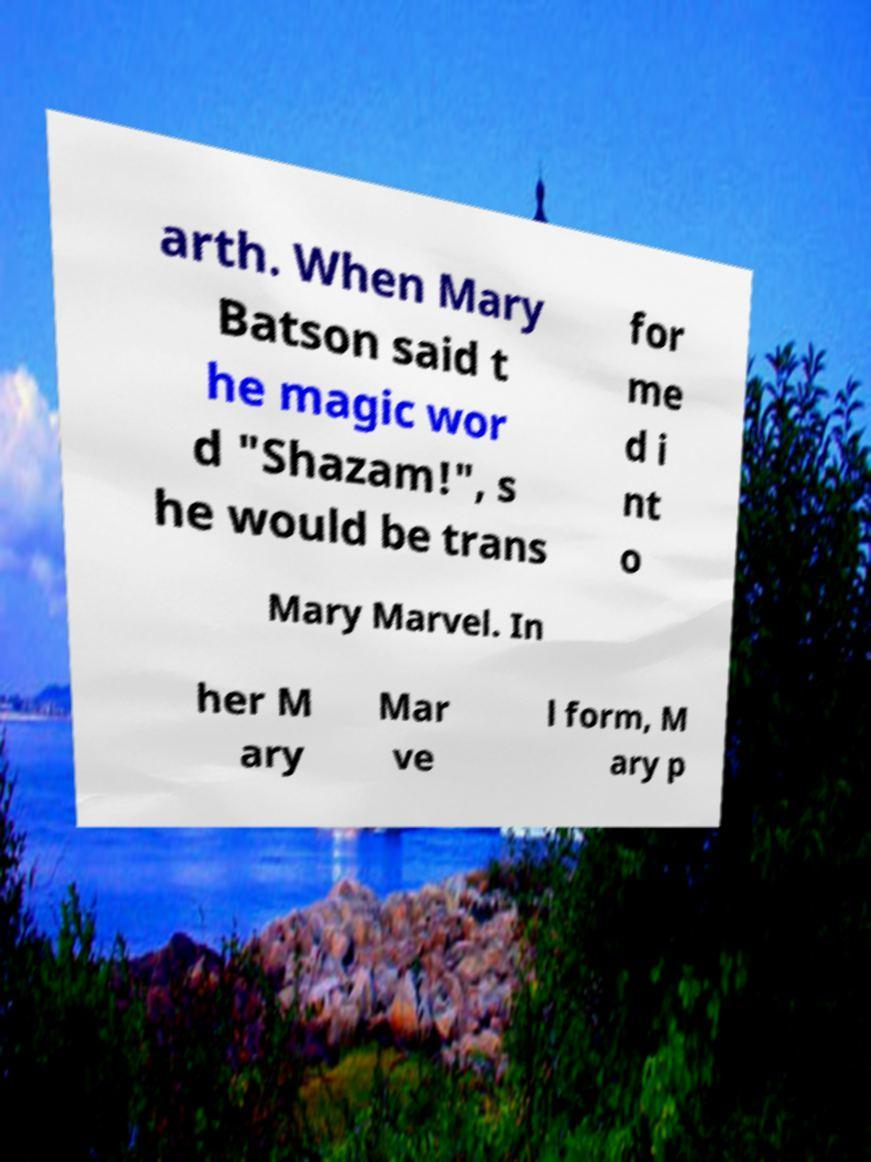What messages or text are displayed in this image? I need them in a readable, typed format. arth. When Mary Batson said t he magic wor d "Shazam!", s he would be trans for me d i nt o Mary Marvel. In her M ary Mar ve l form, M ary p 